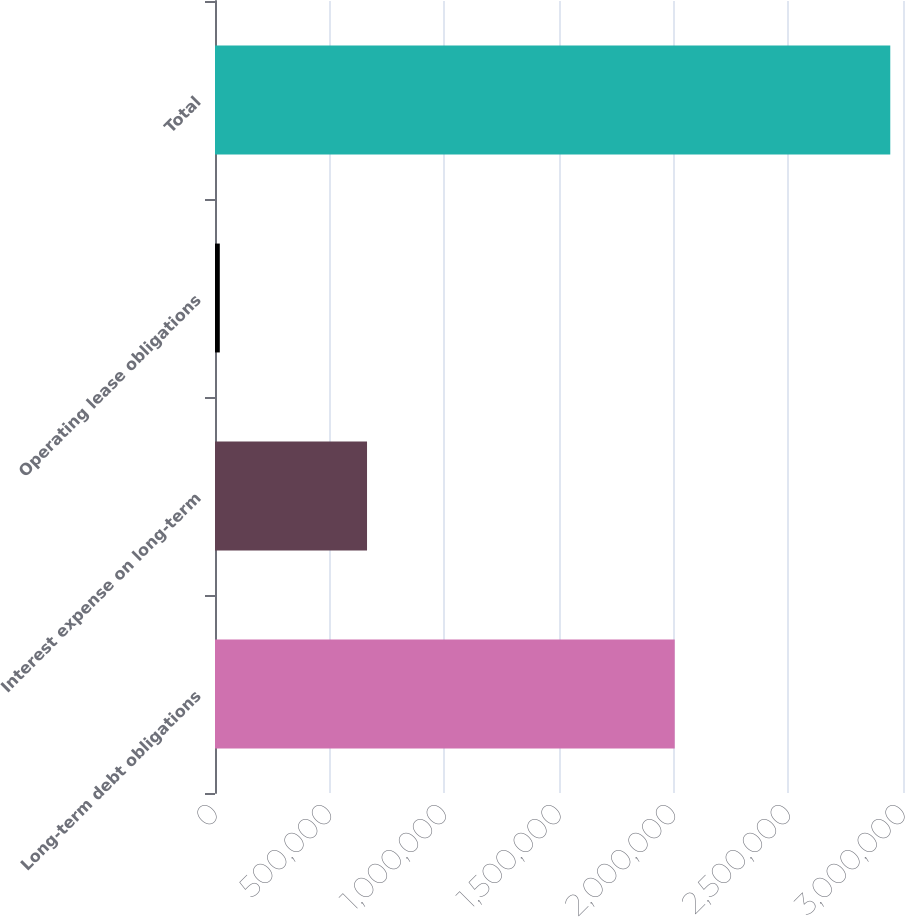Convert chart to OTSL. <chart><loc_0><loc_0><loc_500><loc_500><bar_chart><fcel>Long-term debt obligations<fcel>Interest expense on long-term<fcel>Operating lease obligations<fcel>Total<nl><fcel>2.00463e+06<fcel>662942<fcel>20915<fcel>2.94452e+06<nl></chart> 